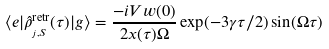Convert formula to latex. <formula><loc_0><loc_0><loc_500><loc_500>\langle e | \hat { \rho } ^ { \text {retr} } _ { _ { j , S } } ( \tau ) | g \rangle = \frac { - i V w ( 0 ) } { 2 x ( \tau ) \Omega } \exp ( - 3 \gamma \tau / 2 ) \sin ( \Omega \tau )</formula> 